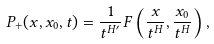Convert formula to latex. <formula><loc_0><loc_0><loc_500><loc_500>P _ { + } ( x , x _ { 0 } , t ) = \frac { 1 } { t ^ { H ^ { \prime } } } F \left ( \frac { x } { t ^ { H } } , \frac { x _ { 0 } } { t ^ { H } } \right ) ,</formula> 